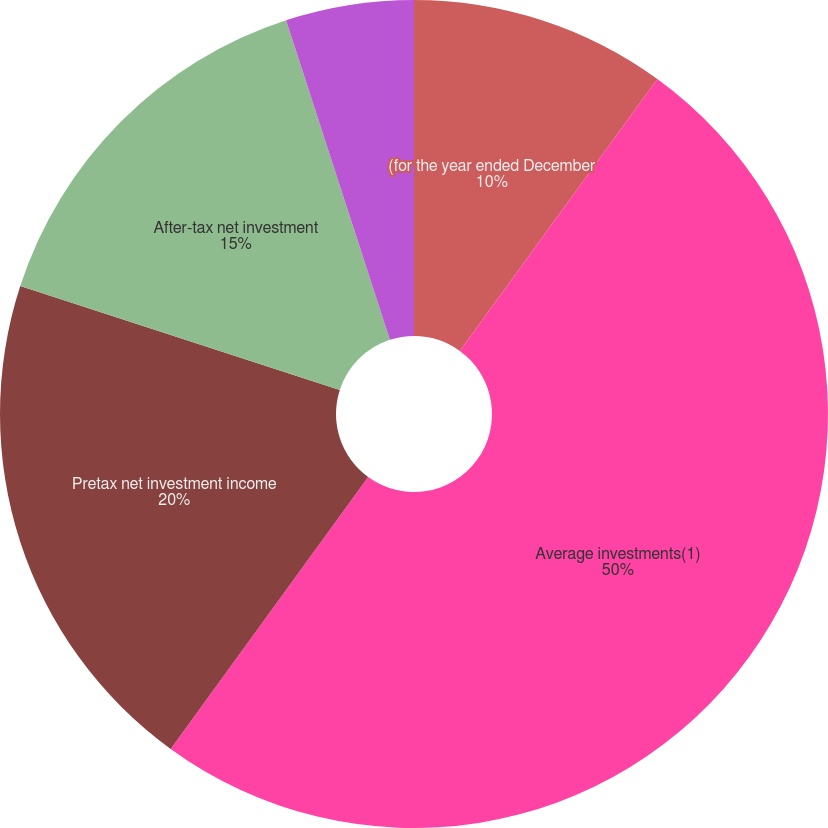Convert chart to OTSL. <chart><loc_0><loc_0><loc_500><loc_500><pie_chart><fcel>(for the year ended December<fcel>Average investments(1)<fcel>Pretax net investment income<fcel>After-tax net investment<fcel>Average pretax yield(2)<fcel>Average after-tax yield(2)<nl><fcel>10.0%<fcel>50.0%<fcel>20.0%<fcel>15.0%<fcel>5.0%<fcel>0.0%<nl></chart> 